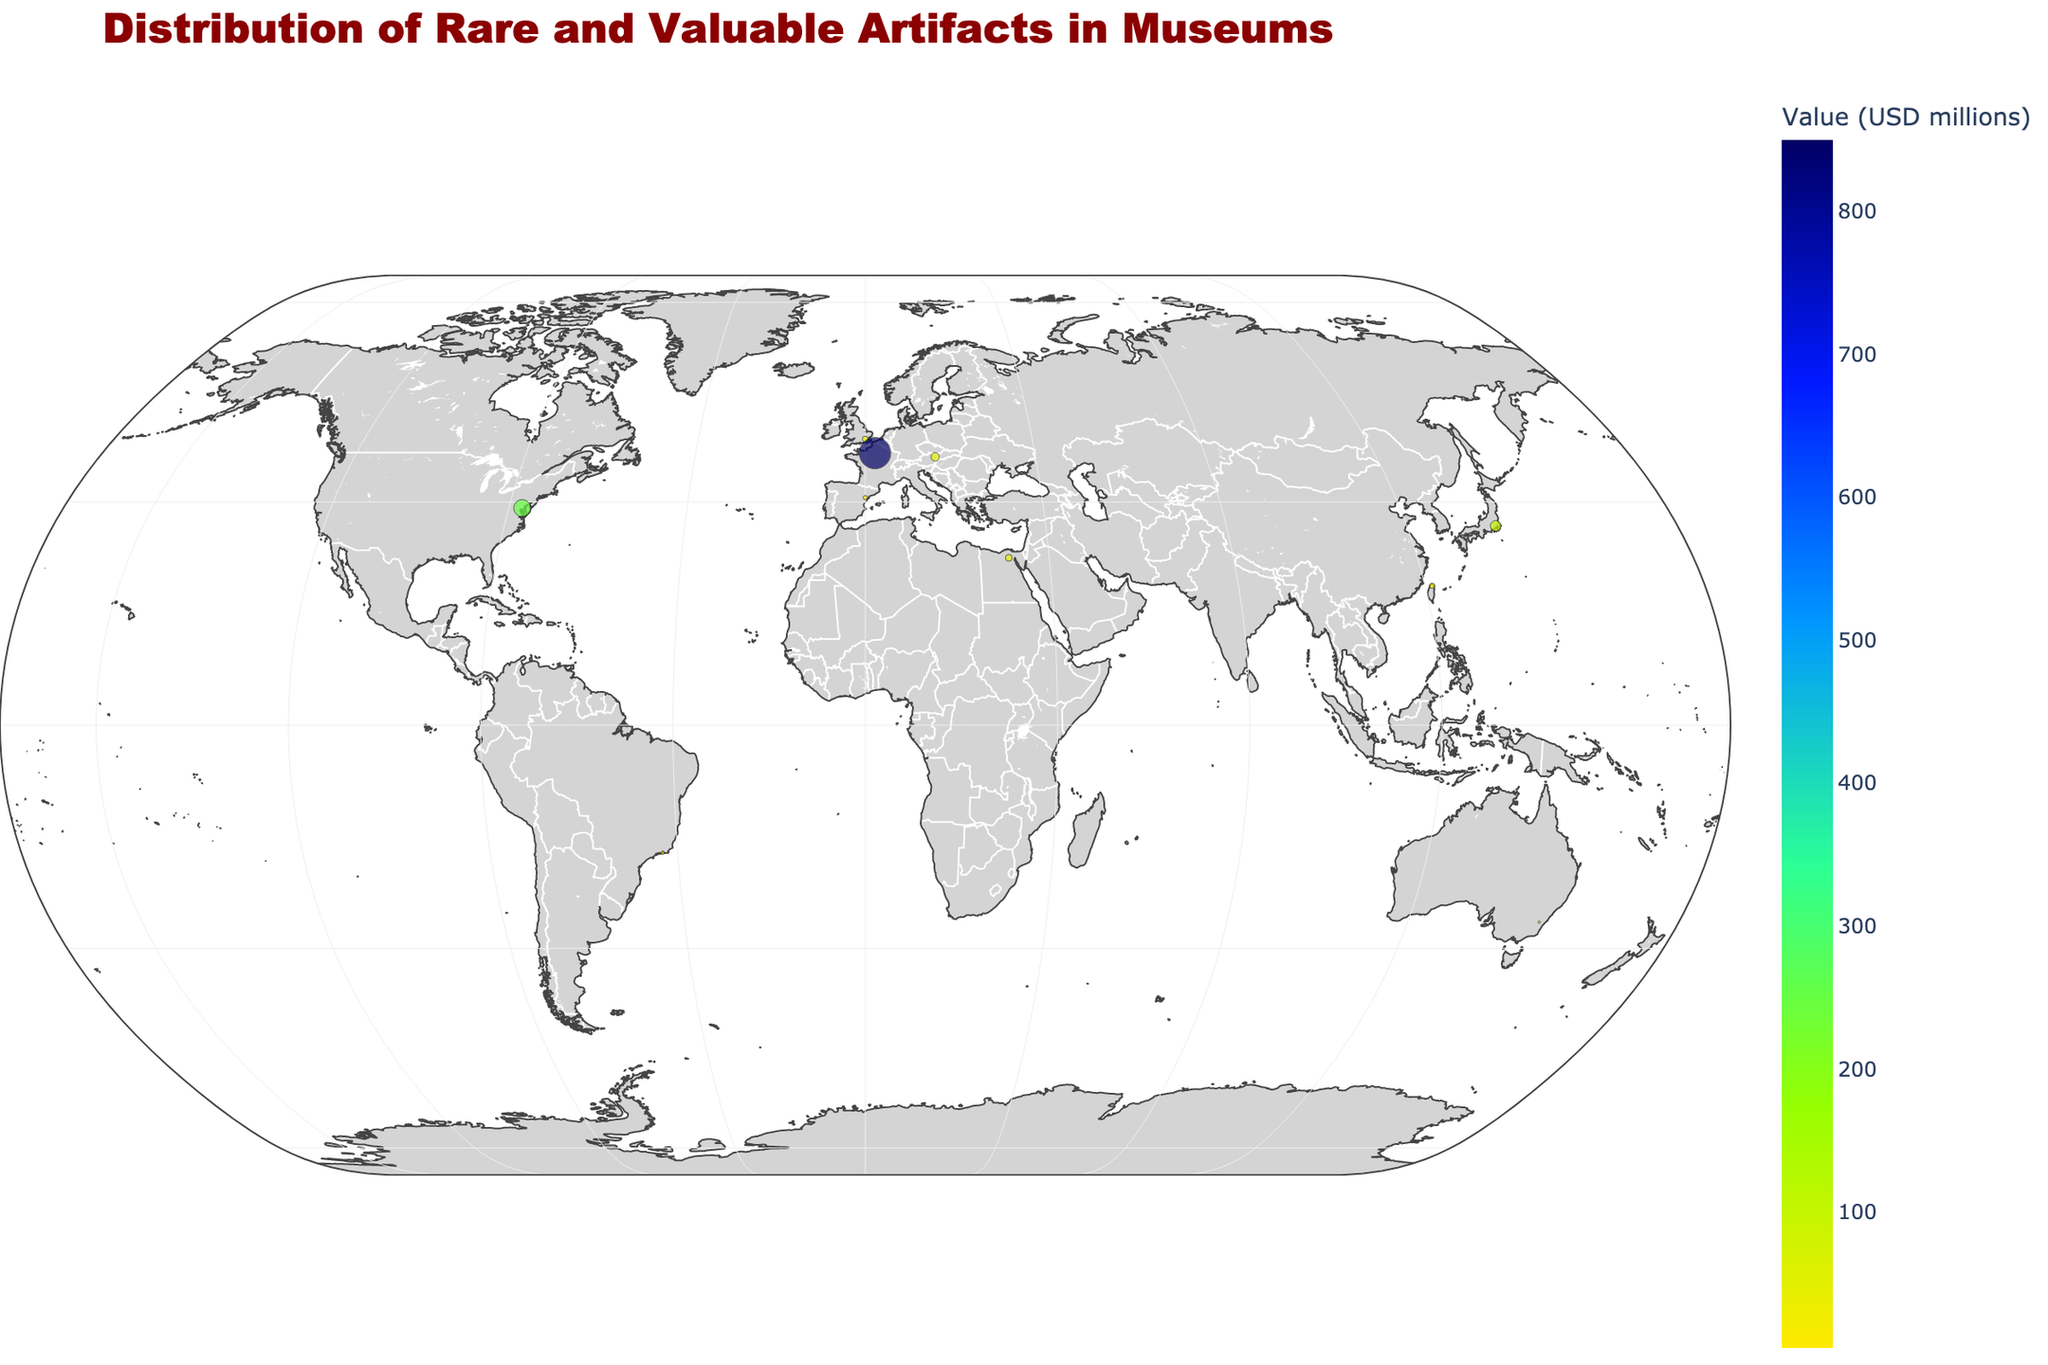What is the title of the plot? The title is the largest and most prominent text, usually placed at the top center of the plot. It summarizes the main topic of the figure.
Answer: Distribution of Rare and Valuable Artifacts in Museums How many data points (artifact locations) are visible on the map? The data points are represented by markers on the map. Counting these markers gives the total number of artifacts plotted.
Answer: 10 Which continent has the most valuable artifact on display in its museums? By observing the color and size of the markers, the continents with the largest and brightest marker typically denote higher values. The tooltip or information box provides exact values.
Answer: Europe Which museum has an artifact with the highest security level and what artifact is it? Hover over or click on the marker corresponding to the museum to see the artifact and its details, including the security level.
Answer: Louvre Museum, Mona Lisa What is the total value of artifacts on display in North America? Identify the data points for North America and sum their values given in the tooltips or markers.
Answer: 265 (15 + 250) How many continents have artifacts with a security level less than 'Extreme'? Examine the details in the tooltips or markers for each data point and count the continents that meet the specified security criteria.
Answer: 3 (North America, South America, Australia) Which continent has the least valuable artifact, and what is its value? Look for the smallest and darkest colored marker, and then check its tooltip to find the name of the continent and the value.
Answer: Australia, 5 How does the value of the Hope Diamond compare to the Sword of Kusanagi? Find the markers for both artifacts, observe their values, and perform a comparison.
Answer: The Hope Diamond is more valuable than the Sword of Kusanagi What is the average value of artifacts displayed in European museums? Identify European artifacts, sum their values, and divide by the number of those artifacts to find the average value.
Answer: 313.33 ((30 + 850 + 60) / 3) Which museum in Asia holds the most valuable artifact and what is the artifact? Review the markers in Asia, identify the one with the highest value by examining the tooltips, and note the artifact.
Answer: Tokyo National Museum, Sword of Kusanagi 